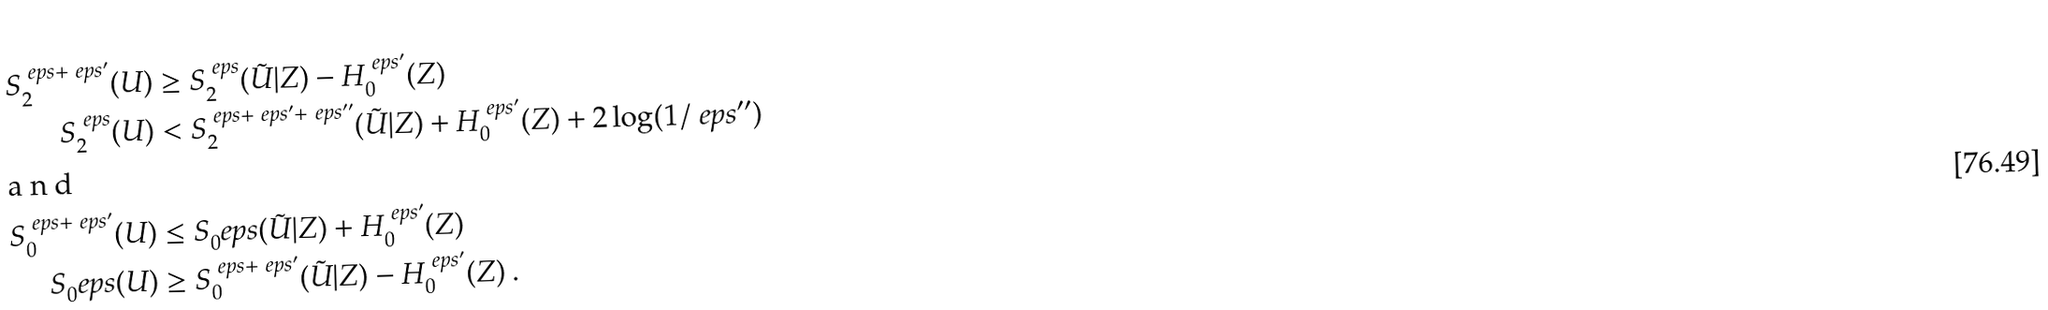<formula> <loc_0><loc_0><loc_500><loc_500>S _ { 2 } ^ { \ e p s + \ e p s ^ { \prime } } ( U ) & \geq S _ { 2 } ^ { \ e p s } ( \tilde { U } | Z ) - H _ { 0 } ^ { \ e p s ^ { \prime } } ( Z ) \\ S _ { 2 } ^ { \ e p s } ( U ) & < S _ { 2 } ^ { \ e p s + \ e p s ^ { \prime } + \ e p s ^ { \prime \prime } } ( \tilde { U } | Z ) + H _ { 0 } ^ { \ e p s ^ { \prime } } ( Z ) + 2 \log ( 1 / \ e p s ^ { \prime \prime } ) \\ \intertext { a n d } S _ { 0 } ^ { \ e p s + \ e p s ^ { \prime } } ( U ) & \leq S _ { 0 } ^ { \ } e p s ( \tilde { U } | Z ) + H _ { 0 } ^ { \ e p s ^ { \prime } } ( Z ) \\ S _ { 0 } ^ { \ } e p s ( U ) & \geq S _ { 0 } ^ { \ e p s + \ e p s ^ { \prime } } ( \tilde { U } | Z ) - H _ { 0 } ^ { \ e p s ^ { \prime } } ( Z ) \ .</formula> 